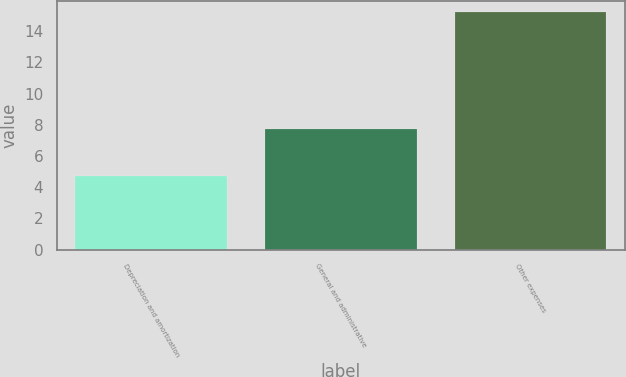<chart> <loc_0><loc_0><loc_500><loc_500><bar_chart><fcel>Depreciation and amortization<fcel>General and administrative<fcel>Other expenses<nl><fcel>4.7<fcel>7.7<fcel>15.2<nl></chart> 